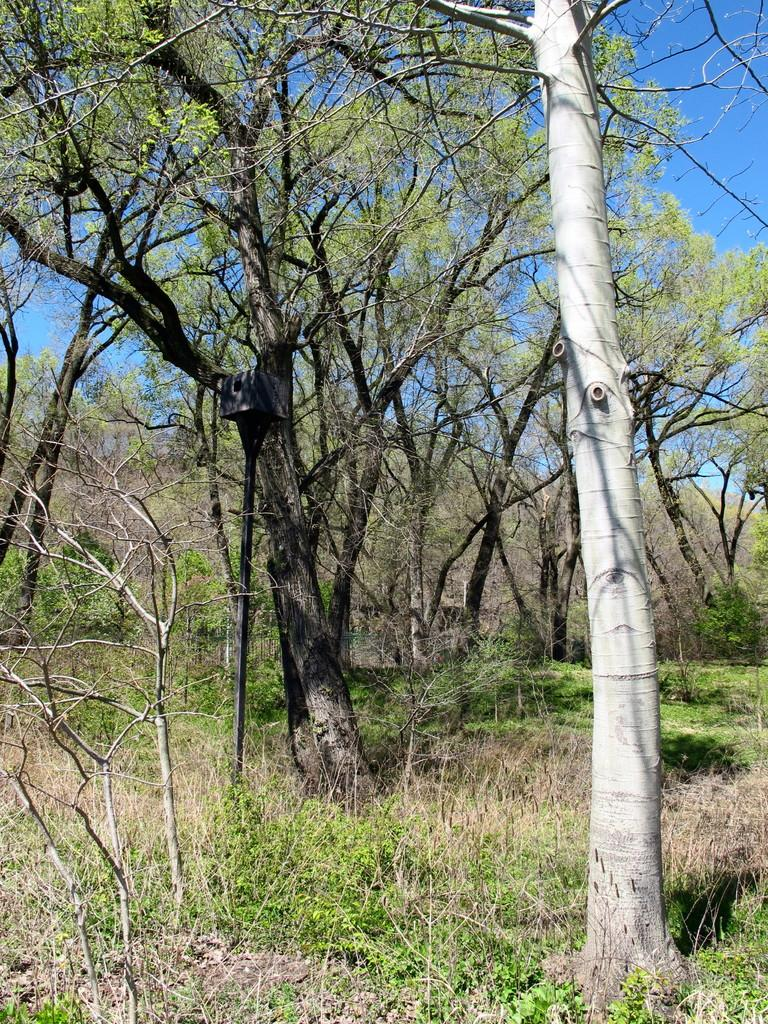What type of vegetation is present in the image? There are many trees in the image. What can be seen in the background of the image? There is a blue sky visible in the background of the image. What type of spark can be seen coming from the trees in the image? There is no spark present in the image; it features trees and a blue sky. What type of vegetable is growing on the trees in the image? There are no vegetables growing on the trees in the image; the trees are not bearing fruit or vegetables. 